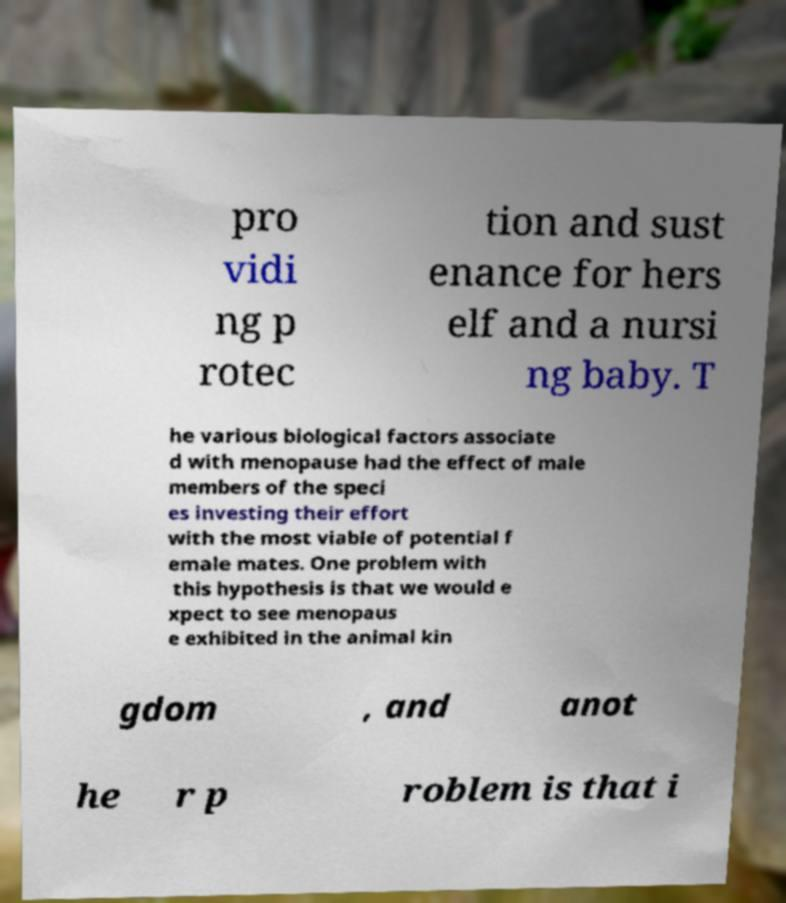What messages or text are displayed in this image? I need them in a readable, typed format. pro vidi ng p rotec tion and sust enance for hers elf and a nursi ng baby. T he various biological factors associate d with menopause had the effect of male members of the speci es investing their effort with the most viable of potential f emale mates. One problem with this hypothesis is that we would e xpect to see menopaus e exhibited in the animal kin gdom , and anot he r p roblem is that i 